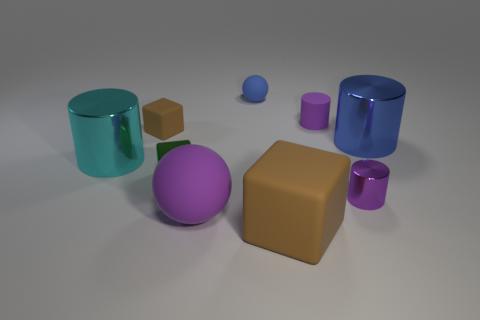What number of cyan things are big matte balls or big cylinders?
Your answer should be compact. 1. How many shiny things have the same color as the matte cylinder?
Your answer should be compact. 1. Does the small brown block have the same material as the large brown block?
Ensure brevity in your answer.  Yes. There is a brown rubber thing left of the tiny green block; what number of spheres are behind it?
Your answer should be compact. 1. Is the size of the blue ball the same as the cyan thing?
Offer a terse response. No. How many purple objects have the same material as the big purple ball?
Provide a short and direct response. 1. The purple matte thing that is the same shape as the blue shiny thing is what size?
Keep it short and to the point. Small. Is the shape of the purple rubber thing to the left of the big brown matte block the same as  the cyan shiny object?
Your response must be concise. No. There is a brown thing that is to the right of the cube that is behind the cyan metallic thing; what is its shape?
Give a very brief answer. Cube. The other large thing that is the same shape as the large blue object is what color?
Offer a very short reply. Cyan. 